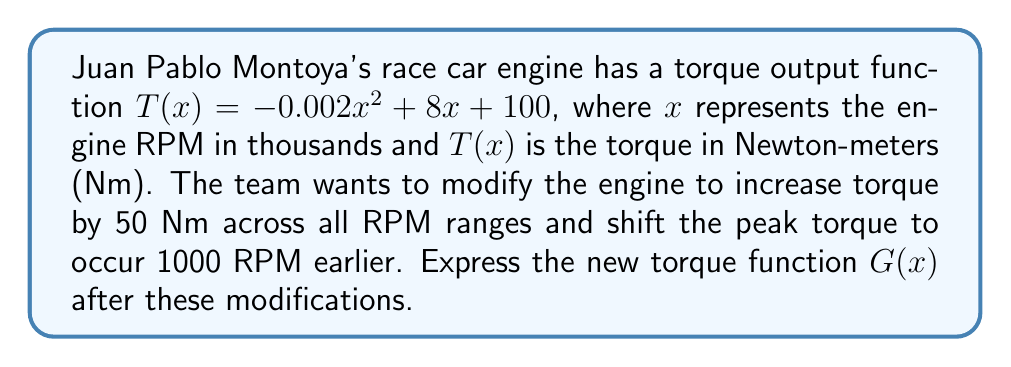Could you help me with this problem? To solve this problem, we need to apply function transformations:

1. Increasing torque by 50 Nm across all RPM ranges:
   This is a vertical shift upward by 50 units.
   $T_1(x) = T(x) + 50 = -0.002x^2 + 8x + 150$

2. Shifting the peak torque to occur 1000 RPM earlier:
   This is a horizontal shift to the right by 1 unit (since x is in thousands of RPM).
   $G(x) = T_1(x+1) = -0.002(x+1)^2 + 8(x+1) + 150$

3. Expand the equation:
   $G(x) = -0.002(x^2 + 2x + 1) + 8x + 8 + 150$
   $G(x) = -0.002x^2 - 0.004x - 0.002 + 8x + 158$

4. Simplify:
   $G(x) = -0.002x^2 + 7.996x + 157.998$

Therefore, the new torque function $G(x)$ after the modifications is:
$G(x) = -0.002x^2 + 7.996x + 157.998$
Answer: $G(x) = -0.002x^2 + 7.996x + 157.998$ 